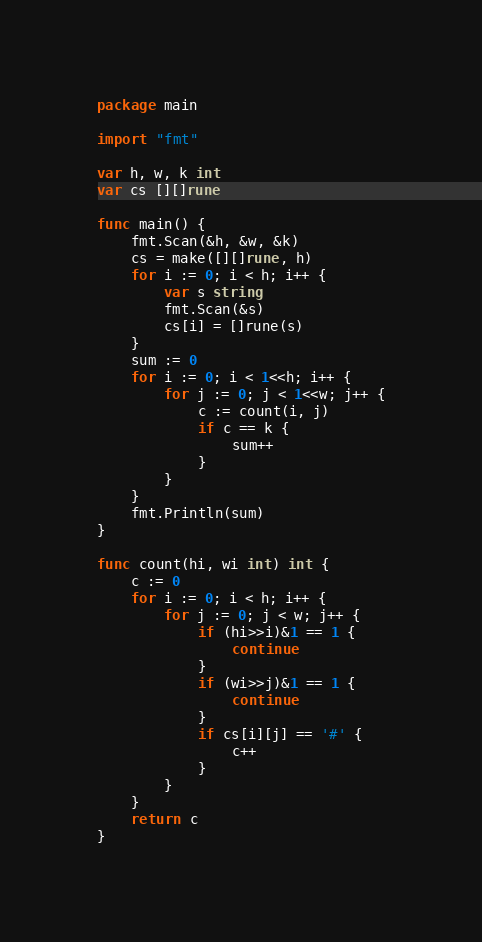Convert code to text. <code><loc_0><loc_0><loc_500><loc_500><_Go_>package main

import "fmt"

var h, w, k int
var cs [][]rune

func main() {
	fmt.Scan(&h, &w, &k)
	cs = make([][]rune, h)
	for i := 0; i < h; i++ {
		var s string
		fmt.Scan(&s)
		cs[i] = []rune(s)
	}
	sum := 0
	for i := 0; i < 1<<h; i++ {
		for j := 0; j < 1<<w; j++ {
			c := count(i, j)
			if c == k {
				sum++
			}
		}
	}
	fmt.Println(sum)
}

func count(hi, wi int) int {
	c := 0
	for i := 0; i < h; i++ {
		for j := 0; j < w; j++ {
			if (hi>>i)&1 == 1 {
				continue
			}
			if (wi>>j)&1 == 1 {
				continue
			}
			if cs[i][j] == '#' {
				c++
			}
		}
	}
	return c
}
</code> 